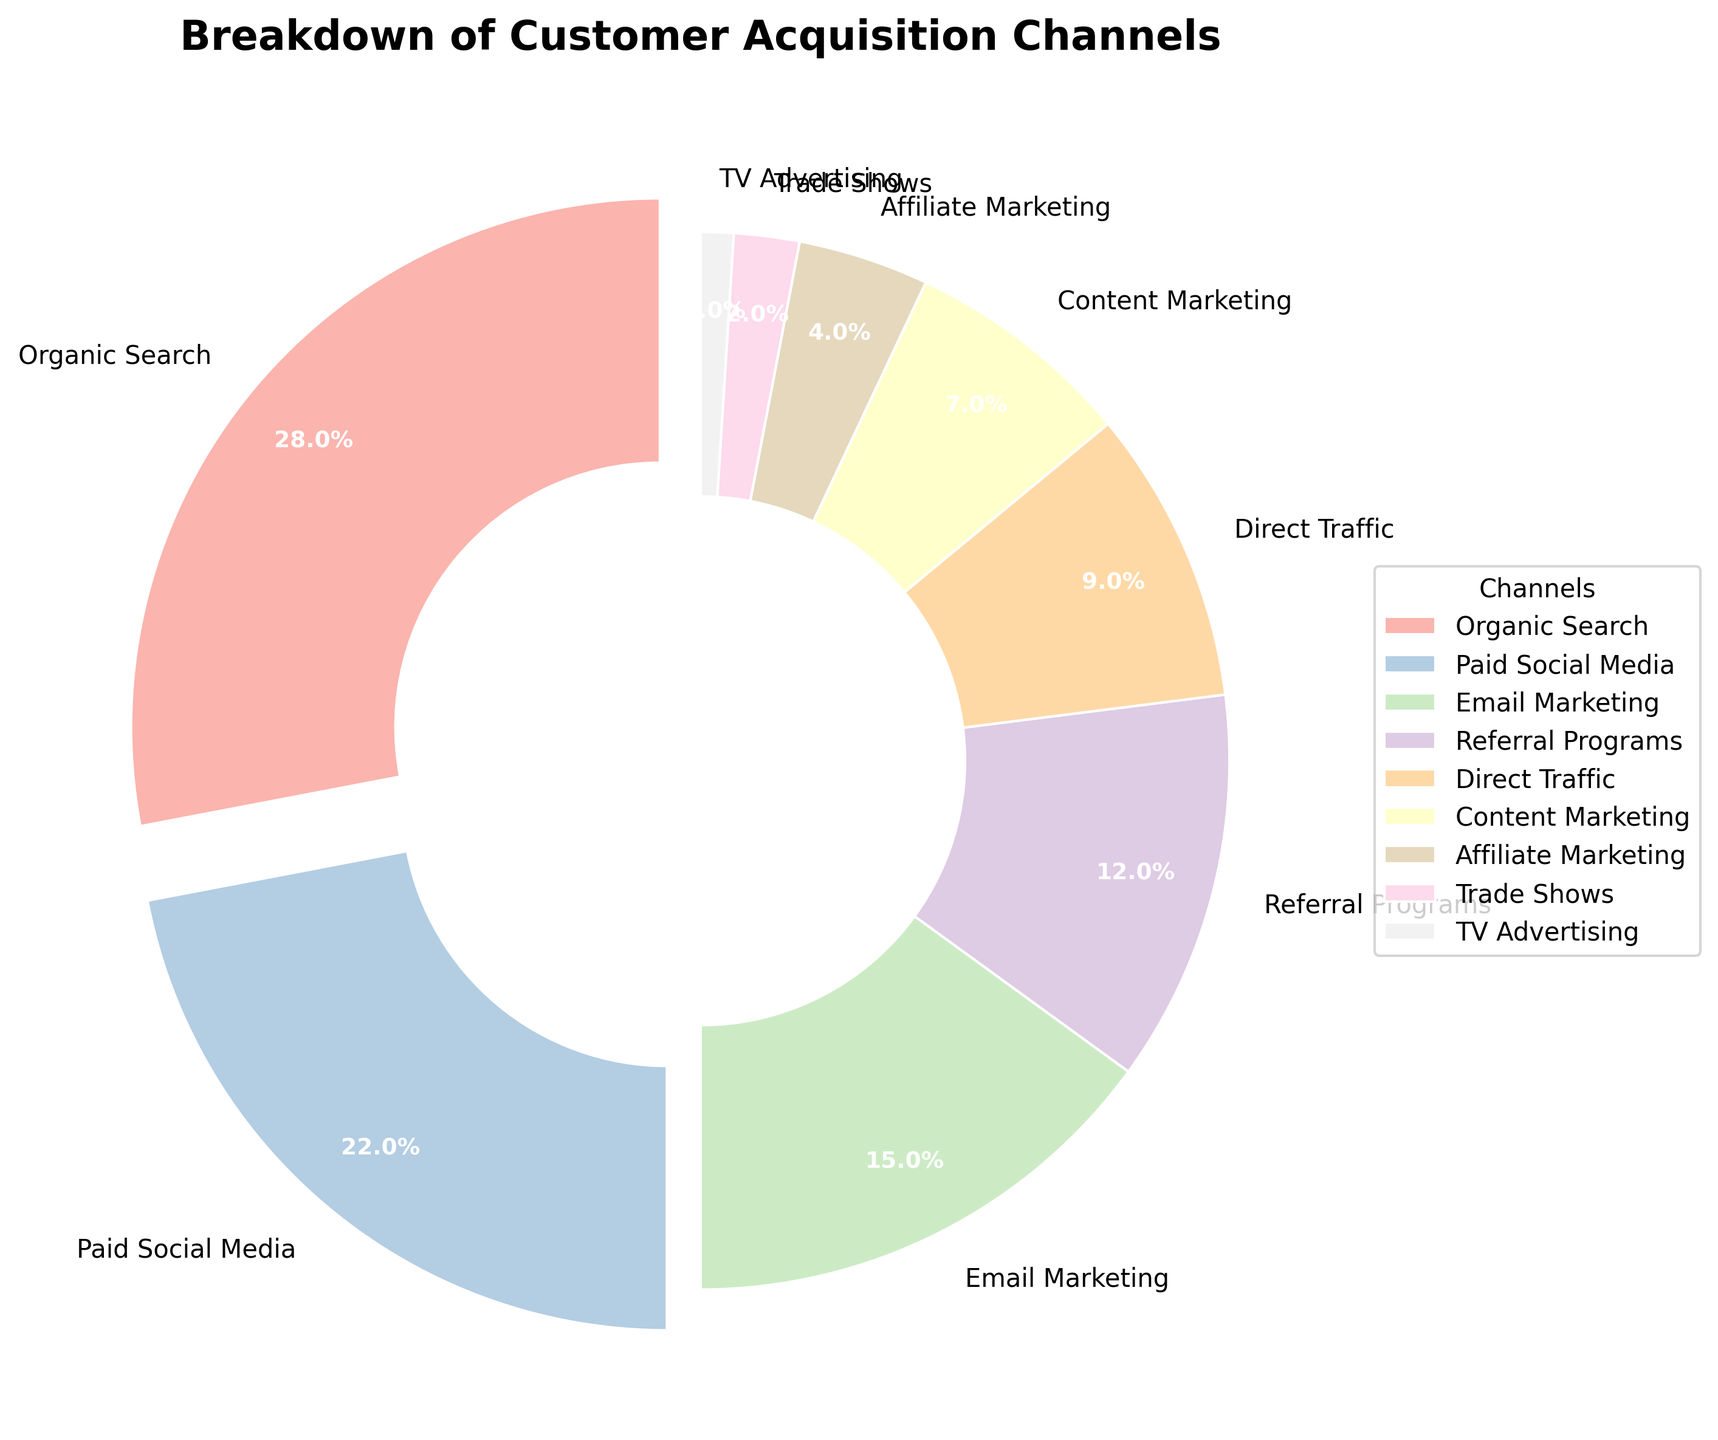What percentage of customer acquisition is achieved through email marketing? Locate the segment labeled "Email Marketing." The corresponding percentage provided is 15%.
Answer: 15% What are the top three customer acquisition channels by percentage? Identify the segments with the highest percentages. The top three are Organic Search (28%), Paid Social Media (22%), and Email Marketing (15%).
Answer: Organic Search, Paid Social Media, Email Marketing How much higher is the percentage of Organic Search compared to Direct Traffic? Find the percentages for Organic Search (28%) and Direct Traffic (9%). Subtract the percentage of Direct Traffic from Organic Search: 28% - 9% = 19%.
Answer: 19% What is the combined percentage of Referral Programs and Content Marketing? Find the percentages for Referral Programs (12%) and Content Marketing (7%). Add these percentages together: 12% + 7% = 19%.
Answer: 19% Which channel contributes the least to customer acquisition and what is the percentage? Identify the segment with the smallest percentage. The smallest percentage is for TV Advertising, which is 1%.
Answer: TV Advertising, 1% How many channels have a percentage greater than 10%? Count the segments with percentages greater than 10%. They are Organic Search (28%), Paid Social Media (22%), Email Marketing (15%), and Referral Programs (12%), totaling 4 channels.
Answer: 4 By how much does Paid Social Media exceed Content Marketing in terms of percentage? Find the percentages for Paid Social Media (22%) and Content Marketing (7%). Subtract Content Marketing's percentage from Paid Social Media's: 22% - 7% = 15%.
Answer: 15% What is the share of all channels except Organic Search, Paid Social Media, and Email Marketing? Sum the percentages for all channels other than Organic Search (28%), Paid Social Media (22%), and Email Marketing (15%). The remaining channels are Referral Programs (12%), Direct Traffic (9%), Content Marketing (7%), Affiliate Marketing (4%), Trade Shows (2%), and TV Advertising (1%), which sum to: 12% + 9% + 7% + 4% + 2% + 1% = 35%.
Answer: 35% Which two channels have the closest percentages? Compare the percentages to determine the closest ones. Direct Traffic (9%) and Content Marketing (7%) have the closest percentages with a 2% difference.
Answer: Direct Traffic and Content Marketing What is the average percentage for all customer acquisition channels? Add all the percentages: 28% + 22% + 15% + 12% + 9% + 7% + 4% + 2% + 1% = 100%. Since there are 9 channels, divide 100% by 9: 100% / 9 ≈ 11.1%.
Answer: 11.1% 